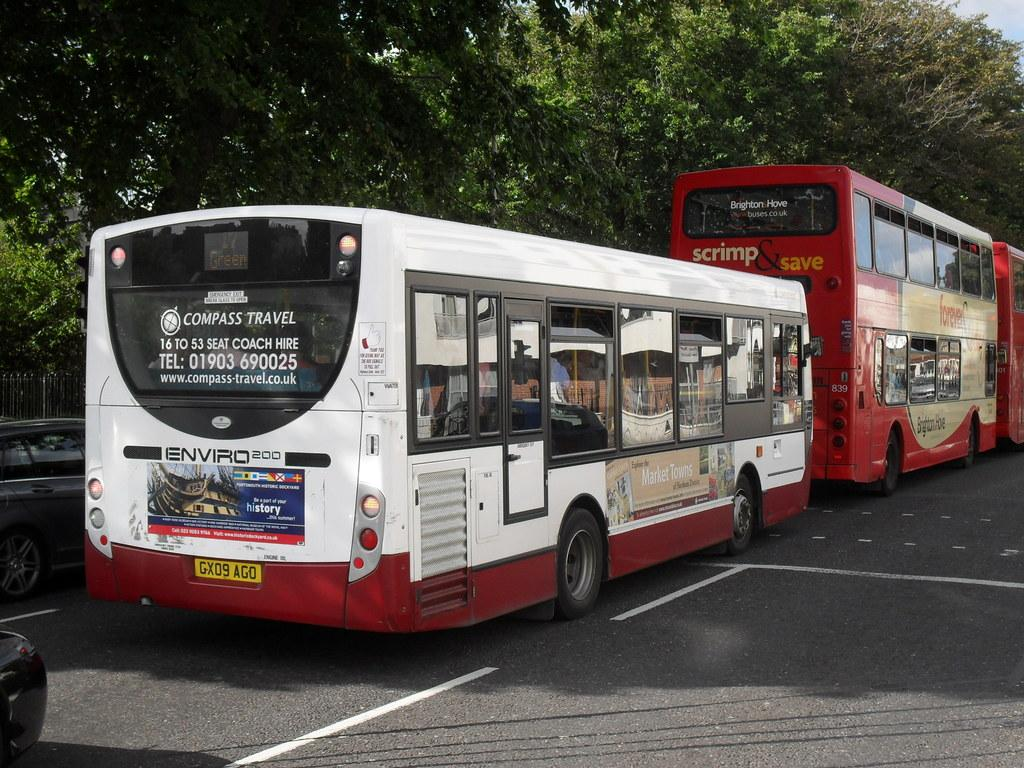What can be seen on the road in the image? There are vehicles on the road in the image. What type of natural elements are visible in the background of the image? There are trees in the background of the image. What architectural feature can be seen in the background of the image? There is a fence in the background of the image. What part of the natural environment is visible in the image? The sky is visible in the background of the image. What type of sack is being used for health selection in the image? There is no sack or health selection present in the image. What type of health selection is being made in the image? There is no health selection present in the image; it features vehicles on the road and natural elements in the background. 